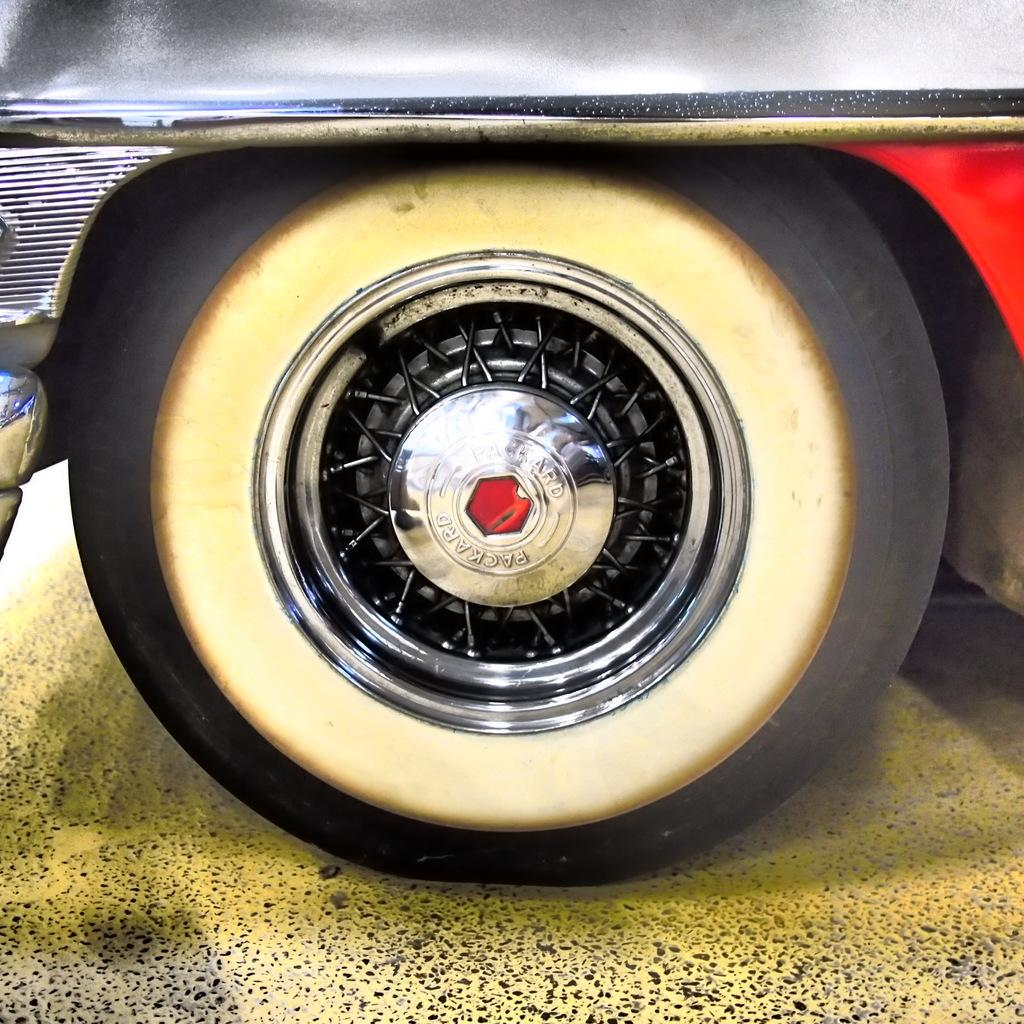What object is the main focus of the image? The main focus of the image is a wheel of a vehicle. What colors are present on the wheel? The wheel is black and yellow in color. What can be seen in the background of the image? There is a path visible in the image. What is the color of the path? The path is yellow in color. What type of disease can be seen affecting the wheel in the image? There is no disease present in the image; it is a wheel of a vehicle with no signs of illness or damage. How many toes can be counted on the wheel in the image? There are no toes present in the image, as it features a wheel of a vehicle. 